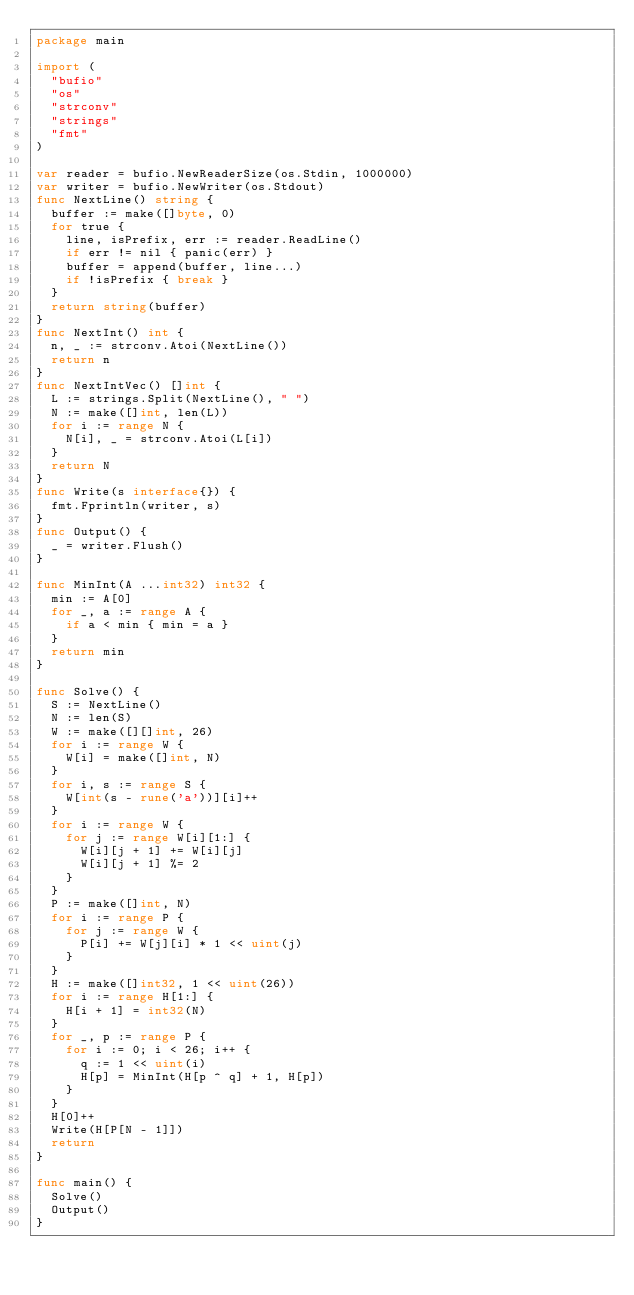<code> <loc_0><loc_0><loc_500><loc_500><_Go_>package main

import (
  "bufio"
  "os"
  "strconv"
  "strings"
  "fmt"
)

var reader = bufio.NewReaderSize(os.Stdin, 1000000)
var writer = bufio.NewWriter(os.Stdout)
func NextLine() string {
  buffer := make([]byte, 0)
  for true {
    line, isPrefix, err := reader.ReadLine()
    if err != nil { panic(err) }
    buffer = append(buffer, line...)
    if !isPrefix { break }
  }
  return string(buffer)
}
func NextInt() int {
  n, _ := strconv.Atoi(NextLine())
  return n
}
func NextIntVec() []int {
  L := strings.Split(NextLine(), " ")
  N := make([]int, len(L))
  for i := range N {
    N[i], _ = strconv.Atoi(L[i])
  }
  return N
}
func Write(s interface{}) {
  fmt.Fprintln(writer, s)
}
func Output() {
  _ = writer.Flush()
}

func MinInt(A ...int32) int32 {
  min := A[0]
  for _, a := range A {
    if a < min { min = a }
  }
  return min
}

func Solve() {
  S := NextLine()
  N := len(S)
  W := make([][]int, 26)
  for i := range W {
    W[i] = make([]int, N)
  }
  for i, s := range S {
    W[int(s - rune('a'))][i]++
  }
  for i := range W {
    for j := range W[i][1:] {
      W[i][j + 1] += W[i][j]
      W[i][j + 1] %= 2
    }
  }
  P := make([]int, N)
  for i := range P {
    for j := range W {
      P[i] += W[j][i] * 1 << uint(j)
    }
  }
  H := make([]int32, 1 << uint(26))
  for i := range H[1:] {
    H[i + 1] = int32(N)
  }
  for _, p := range P {
    for i := 0; i < 26; i++ {
      q := 1 << uint(i)
      H[p] = MinInt(H[p ^ q] + 1, H[p])
    }
  }
  H[0]++
  Write(H[P[N - 1]])
  return
}

func main() {
  Solve()
  Output()
}</code> 